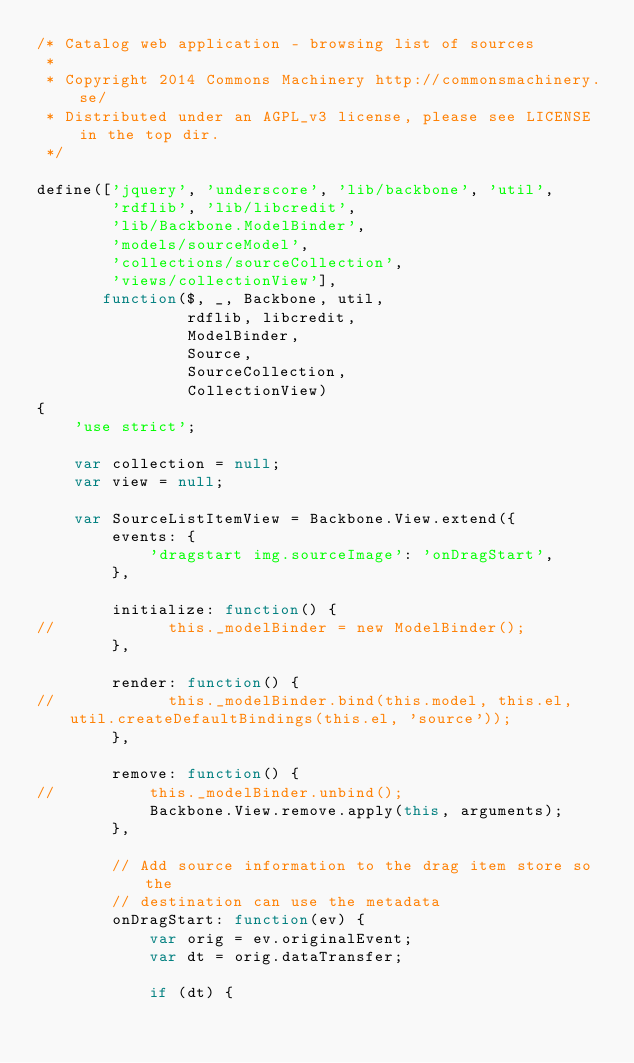<code> <loc_0><loc_0><loc_500><loc_500><_JavaScript_>/* Catalog web application - browsing list of sources
 *
 * Copyright 2014 Commons Machinery http://commonsmachinery.se/
 * Distributed under an AGPL_v3 license, please see LICENSE in the top dir.
 */

define(['jquery', 'underscore', 'lib/backbone', 'util',
        'rdflib', 'lib/libcredit',
        'lib/Backbone.ModelBinder',
        'models/sourceModel',
        'collections/sourceCollection',
        'views/collectionView'],
       function($, _, Backbone, util,
                rdflib, libcredit,
                ModelBinder,
                Source,
                SourceCollection,
                CollectionView)
{
    'use strict';

    var collection = null;
    var view = null;

    var SourceListItemView = Backbone.View.extend({
        events: {
            'dragstart img.sourceImage': 'onDragStart',
        },

        initialize: function() {
//            this._modelBinder = new ModelBinder();
        },

        render: function() {
//            this._modelBinder.bind(this.model, this.el, util.createDefaultBindings(this.el, 'source'));
        },

        remove: function() {
//			this._modelBinder.unbind();
            Backbone.View.remove.apply(this, arguments);
        },

        // Add source information to the drag item store so the
        // destination can use the metadata
        onDragStart: function(ev) {
            var orig = ev.originalEvent;
            var dt = orig.dataTransfer;

            if (dt) {</code> 